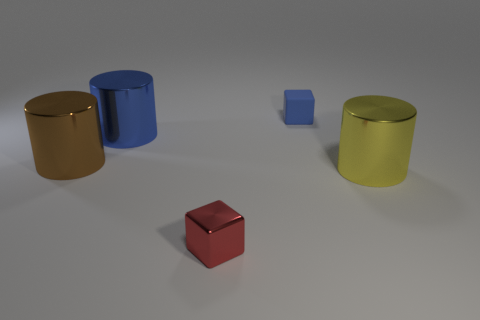Is the big brown object made of the same material as the small blue block?
Keep it short and to the point. No. How many metallic things are blue things or yellow cylinders?
Offer a terse response. 2. There is a large brown thing that is in front of the small matte block; what shape is it?
Offer a very short reply. Cylinder. What is the size of the brown object that is made of the same material as the big yellow thing?
Keep it short and to the point. Large. There is a object that is behind the brown cylinder and on the left side of the tiny blue matte object; what shape is it?
Offer a terse response. Cylinder. Is the color of the cube that is on the right side of the small red thing the same as the tiny metal block?
Ensure brevity in your answer.  No. Do the tiny thing in front of the blue cylinder and the tiny object behind the large blue shiny cylinder have the same shape?
Offer a very short reply. Yes. How big is the cube that is in front of the large blue metal object?
Provide a succinct answer. Small. There is a cylinder on the right side of the red cube that is in front of the blue rubber block; how big is it?
Give a very brief answer. Large. Is the number of blue rubber objects greater than the number of large brown matte objects?
Ensure brevity in your answer.  Yes. 